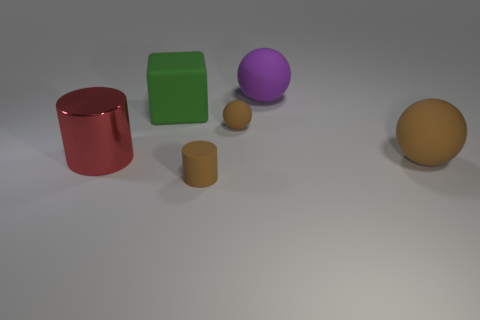What number of small balls have the same color as the matte cylinder?
Your response must be concise. 1. There is a large metallic object; is it the same color as the big thing behind the big green matte object?
Your answer should be compact. No. How many things are big blue metal objects or large rubber objects behind the tiny matte ball?
Provide a short and direct response. 2. What size is the brown matte ball that is right of the matte sphere behind the green matte cube?
Your answer should be very brief. Large. Are there the same number of large brown rubber things that are in front of the purple rubber thing and brown matte spheres behind the big green rubber cube?
Give a very brief answer. No. There is a big ball that is behind the green matte block; is there a red metal cylinder behind it?
Give a very brief answer. No. The green thing that is the same material as the purple ball is what shape?
Your answer should be compact. Cube. Is there any other thing that has the same color as the large cylinder?
Give a very brief answer. No. There is a large object that is right of the large matte sphere that is behind the big green block; what is it made of?
Make the answer very short. Rubber. Are there any brown rubber objects of the same shape as the purple matte object?
Make the answer very short. Yes. 